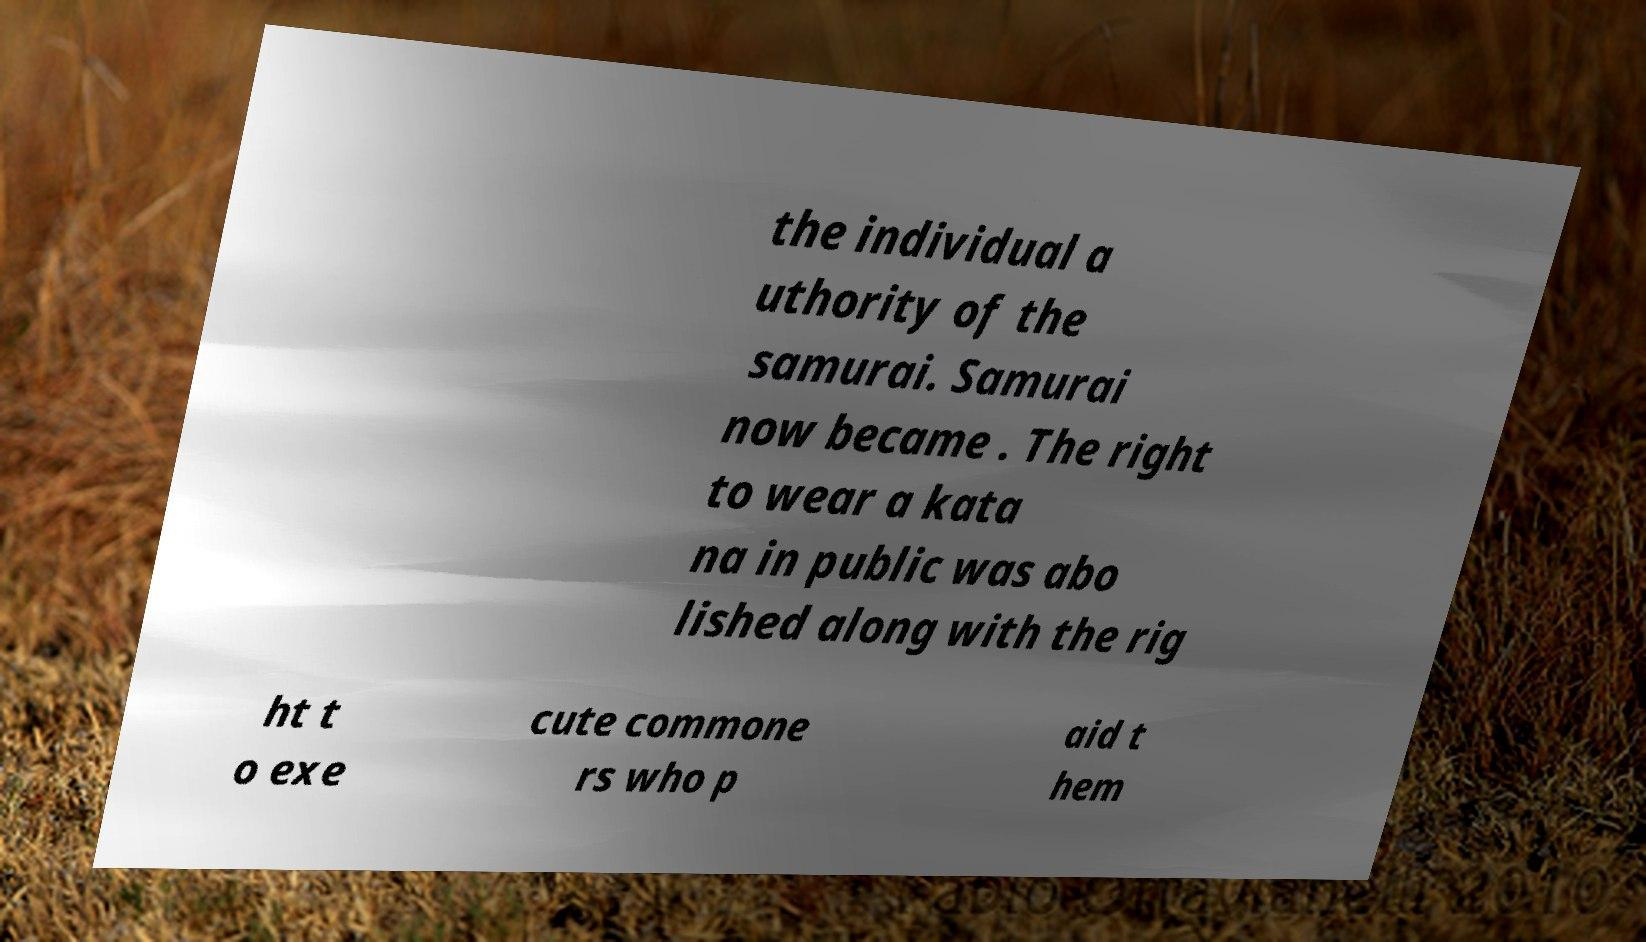I need the written content from this picture converted into text. Can you do that? the individual a uthority of the samurai. Samurai now became . The right to wear a kata na in public was abo lished along with the rig ht t o exe cute commone rs who p aid t hem 